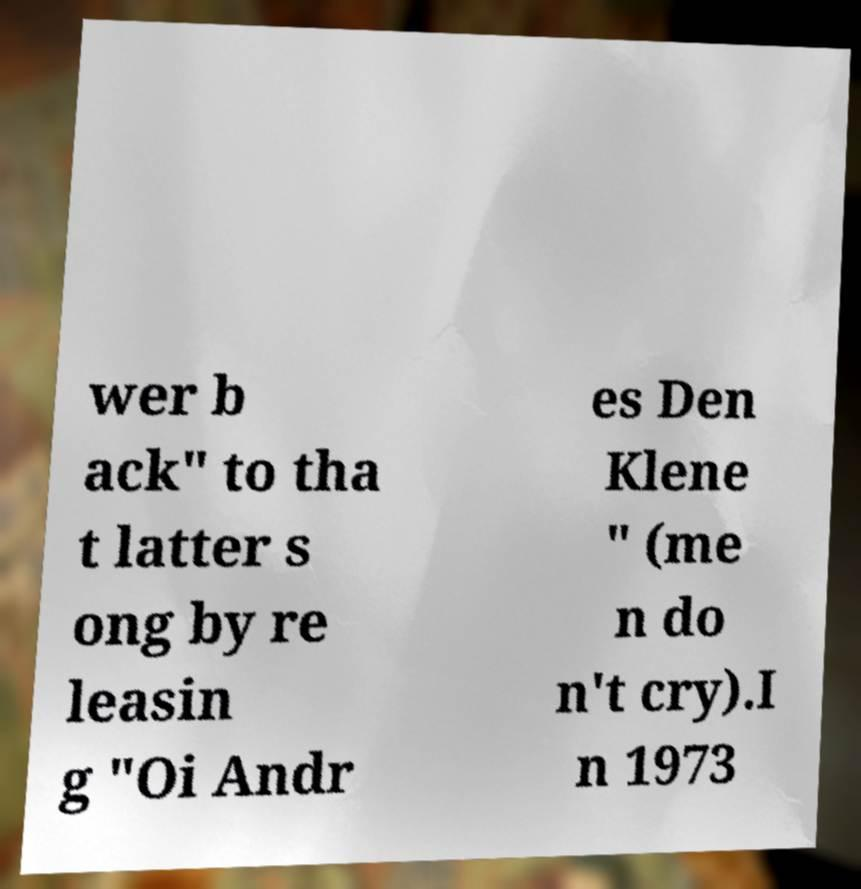There's text embedded in this image that I need extracted. Can you transcribe it verbatim? wer b ack" to tha t latter s ong by re leasin g "Oi Andr es Den Klene " (me n do n't cry).I n 1973 